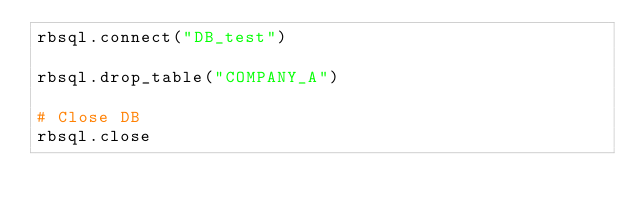<code> <loc_0><loc_0><loc_500><loc_500><_Ruby_>rbsql.connect("DB_test")

rbsql.drop_table("COMPANY_A")

# Close DB
rbsql.close
</code> 